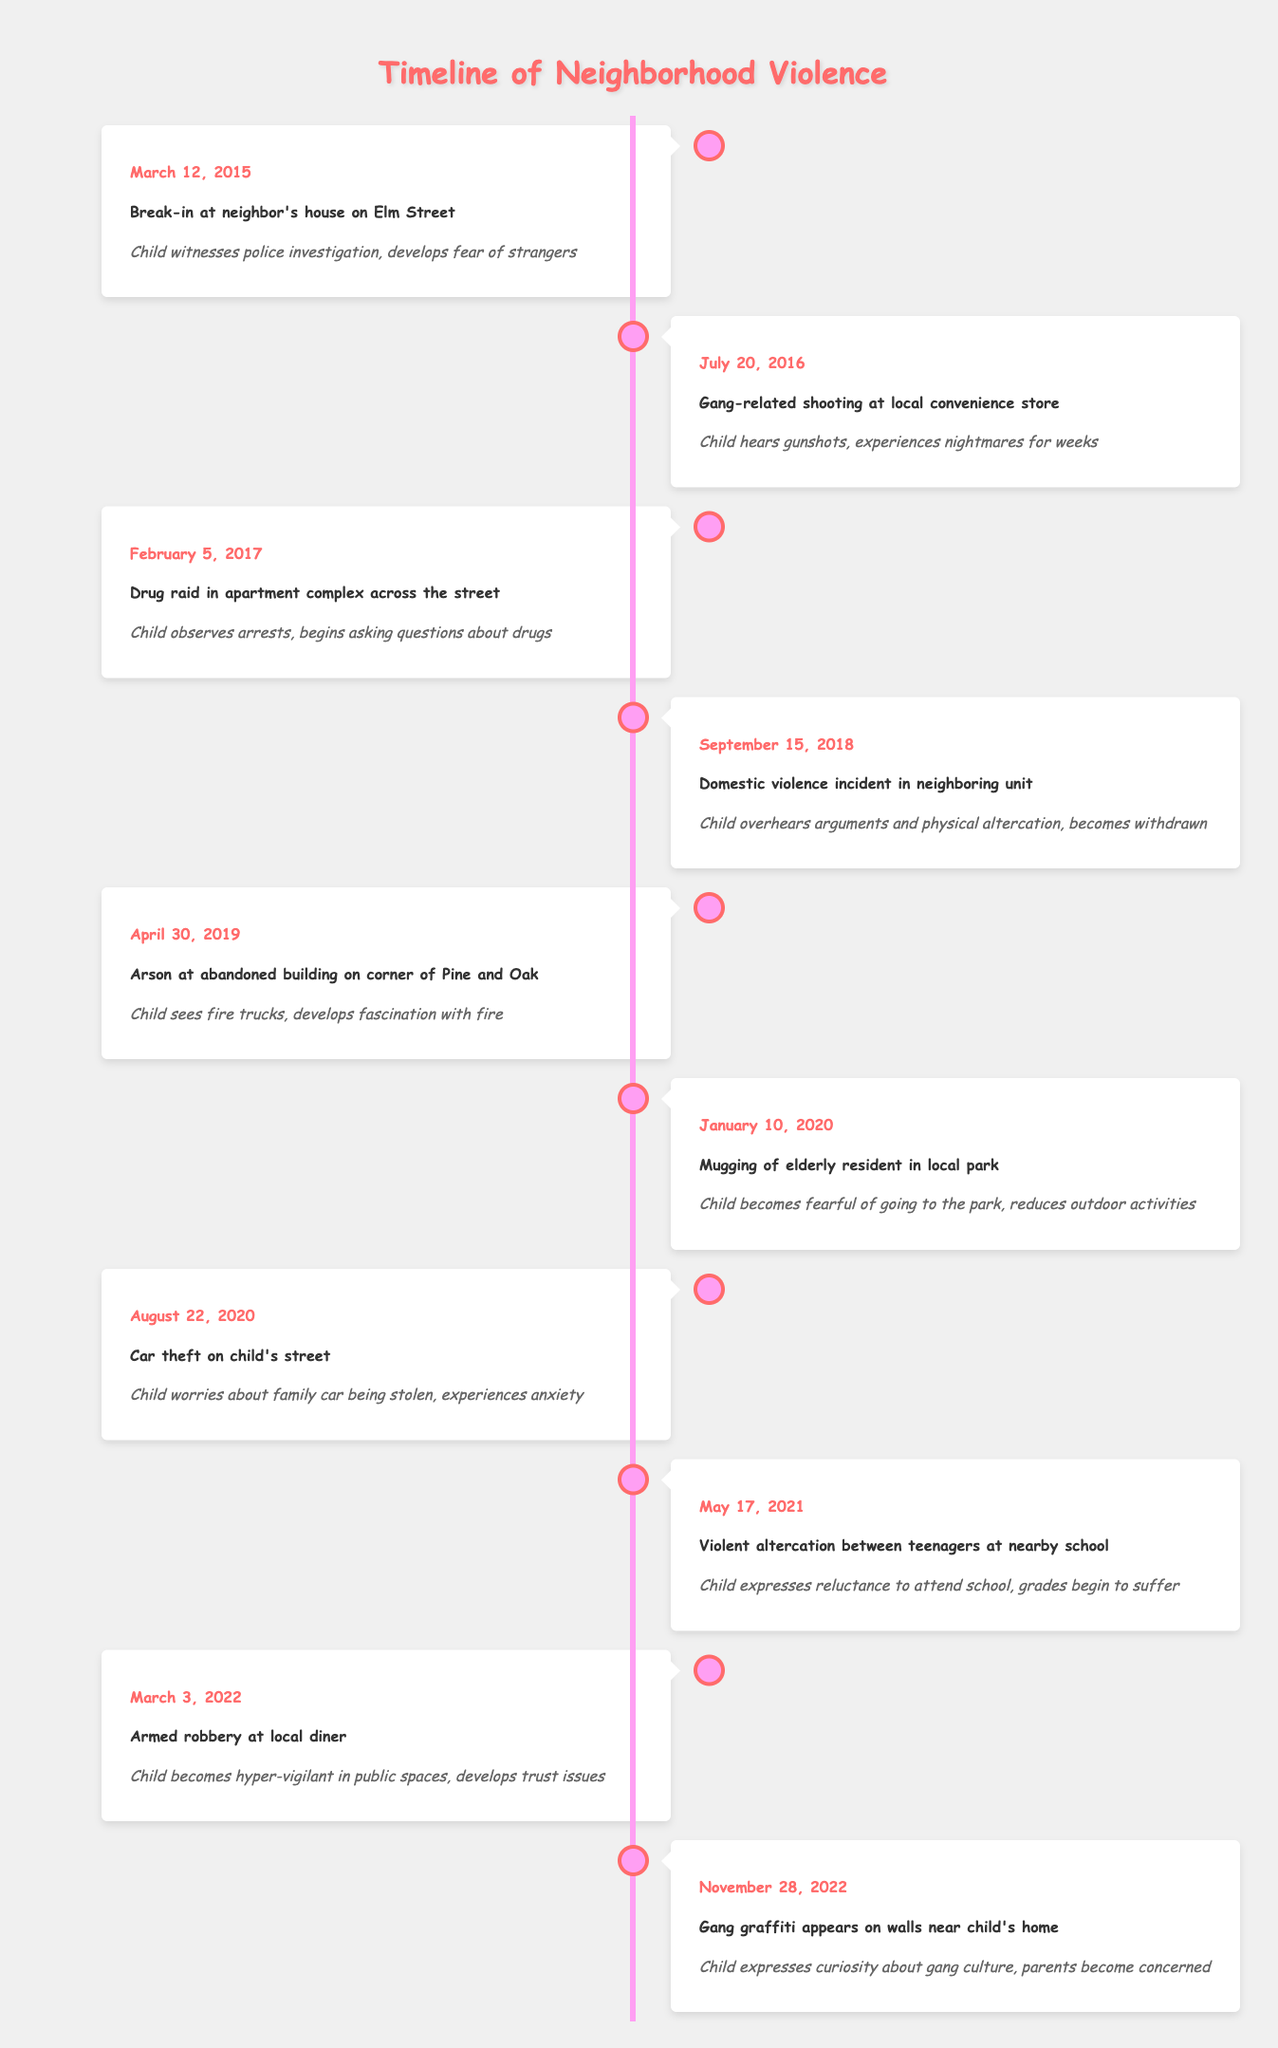What event occurred on July 20, 2016? The table indicates the event was a "Gang-related shooting at local convenience store." This can be found in the row corresponding to that date.
Answer: Gang-related shooting at local convenience store How many incidents involved the police directly? Looking at the table, there are two events specifically mentioning police intervention: the break-in on March 12, 2015, and the drug raid on February 5, 2017. Therefore, the count is two.
Answer: 2 Did the child experience any fear due to neighborhood events? Inspecting the impact column, several entries mention fear such as the break-in leading to fear of strangers, and the mugging causing fear about going to the park. Thus, the answer is yes.
Answer: Yes What impact did the arson on April 30, 2019, have on the child? The impact listed states that the child saw fire trucks and developed a fascination with fire. This can be found in the corresponding row under impact.
Answer: Developed fascination with fire Which incident caused the child to become hyper-vigilant in public spaces? Upon reviewing the entries, the "Armed robbery at local diner" on March 3, 2022, is the specific incident that led to hyper-vigilance in public spaces.
Answer: Armed robbery at local diner What was the frequency of incidents involving gun violence? The table lists two incidents involving gun violence: the gang-related shooting on July 20, 2016, and the armed robbery on March 3, 2022. So this counts as two instances of gun violence.
Answer: 2 What was the impact of the violent altercation on May 17, 2021, on the child's education? The impact expressed that the child was reluctant to attend school and that their grades began to suffer, as stated in the corresponding row.
Answer: Reluctance to attend school, grades began to suffer How many incidents took place in 2020? From the data, there are two incidents in 2020: the mugging on January 10 and the car theft on August 22. By counting these entries, we find that the total is two incidents.
Answer: 2 Did the incidents increase or decrease in frequency over the years? To analyze the trend, we can look at the number of incidents per year. For instance, there were 2 incidents in 2015, 1 in 2016, 1 in 2017, 1 in 2018, 2 in 2019, and 2 in 2020, followed by 2 incidents in 2021 and 2 incidents in 2022. This shows that the incidents varied but did not demonstrate a clear increasing or decreasing trend overall.
Answer: No clear trend 